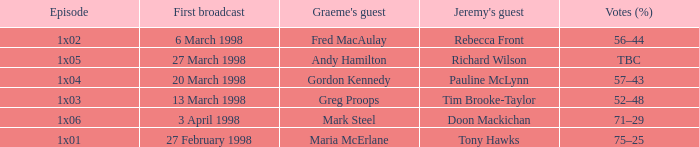What is Graeme's Guest, when Episode is "1x03"? Greg Proops. 